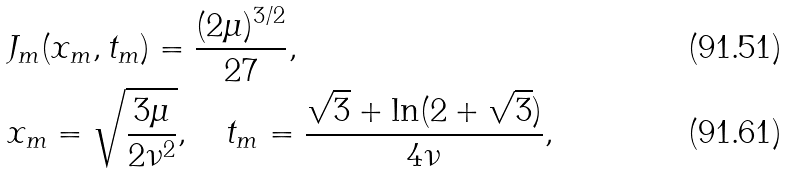Convert formula to latex. <formula><loc_0><loc_0><loc_500><loc_500>& J _ { m } ( x _ { m } , t _ { m } ) = \frac { ( 2 \mu ) ^ { 3 / 2 } } { 2 7 } , \\ & x _ { m } = \sqrt { \frac { 3 \mu } { 2 \nu ^ { 2 } } } , \quad t _ { m } = \frac { \sqrt { 3 } + \ln ( 2 + \sqrt { 3 } ) } { 4 \nu } ,</formula> 